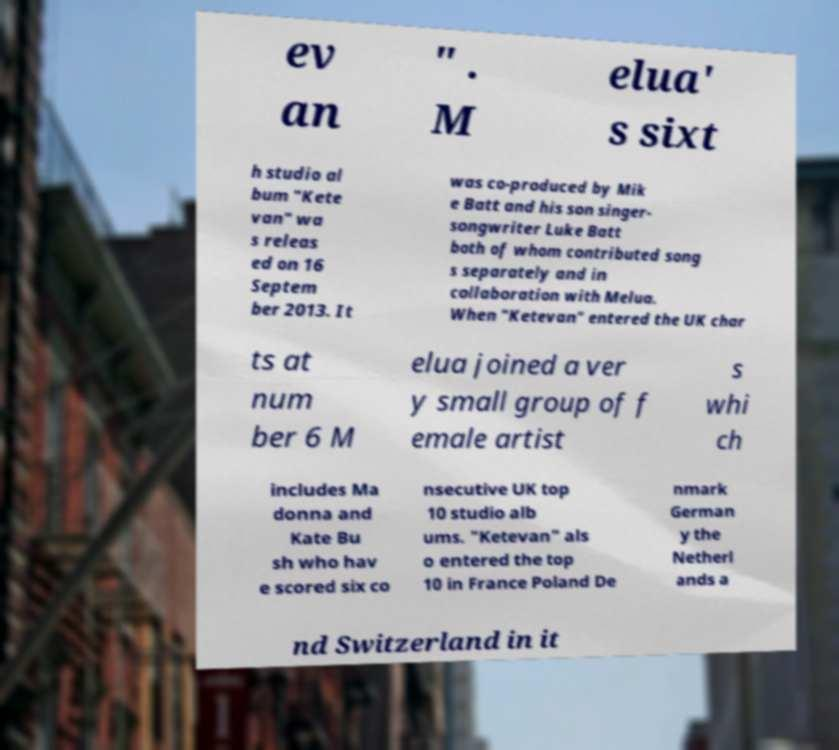Can you read and provide the text displayed in the image?This photo seems to have some interesting text. Can you extract and type it out for me? ev an " . M elua' s sixt h studio al bum "Kete van" wa s releas ed on 16 Septem ber 2013. It was co-produced by Mik e Batt and his son singer- songwriter Luke Batt both of whom contributed song s separately and in collaboration with Melua. When "Ketevan" entered the UK char ts at num ber 6 M elua joined a ver y small group of f emale artist s whi ch includes Ma donna and Kate Bu sh who hav e scored six co nsecutive UK top 10 studio alb ums. "Ketevan" als o entered the top 10 in France Poland De nmark German y the Netherl ands a nd Switzerland in it 